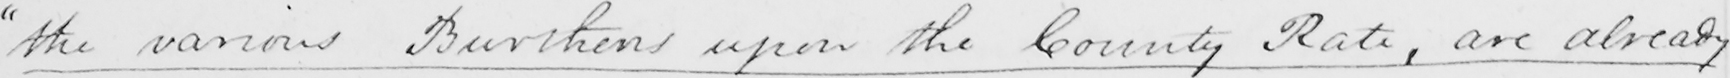Please transcribe the handwritten text in this image. " the various Burthens upon the County Rate , are already 